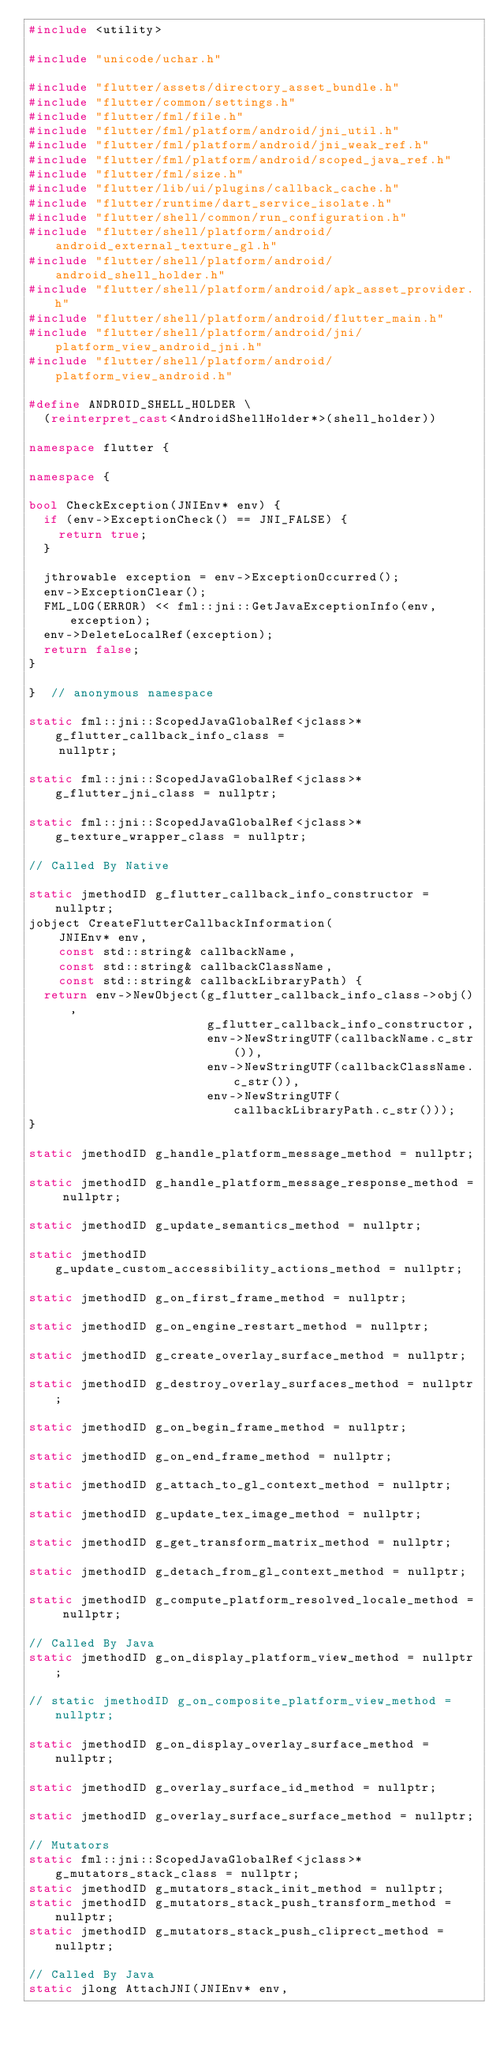Convert code to text. <code><loc_0><loc_0><loc_500><loc_500><_C++_>#include <utility>

#include "unicode/uchar.h"

#include "flutter/assets/directory_asset_bundle.h"
#include "flutter/common/settings.h"
#include "flutter/fml/file.h"
#include "flutter/fml/platform/android/jni_util.h"
#include "flutter/fml/platform/android/jni_weak_ref.h"
#include "flutter/fml/platform/android/scoped_java_ref.h"
#include "flutter/fml/size.h"
#include "flutter/lib/ui/plugins/callback_cache.h"
#include "flutter/runtime/dart_service_isolate.h"
#include "flutter/shell/common/run_configuration.h"
#include "flutter/shell/platform/android/android_external_texture_gl.h"
#include "flutter/shell/platform/android/android_shell_holder.h"
#include "flutter/shell/platform/android/apk_asset_provider.h"
#include "flutter/shell/platform/android/flutter_main.h"
#include "flutter/shell/platform/android/jni/platform_view_android_jni.h"
#include "flutter/shell/platform/android/platform_view_android.h"

#define ANDROID_SHELL_HOLDER \
  (reinterpret_cast<AndroidShellHolder*>(shell_holder))

namespace flutter {

namespace {

bool CheckException(JNIEnv* env) {
  if (env->ExceptionCheck() == JNI_FALSE) {
    return true;
  }

  jthrowable exception = env->ExceptionOccurred();
  env->ExceptionClear();
  FML_LOG(ERROR) << fml::jni::GetJavaExceptionInfo(env, exception);
  env->DeleteLocalRef(exception);
  return false;
}

}  // anonymous namespace

static fml::jni::ScopedJavaGlobalRef<jclass>* g_flutter_callback_info_class =
    nullptr;

static fml::jni::ScopedJavaGlobalRef<jclass>* g_flutter_jni_class = nullptr;

static fml::jni::ScopedJavaGlobalRef<jclass>* g_texture_wrapper_class = nullptr;

// Called By Native

static jmethodID g_flutter_callback_info_constructor = nullptr;
jobject CreateFlutterCallbackInformation(
    JNIEnv* env,
    const std::string& callbackName,
    const std::string& callbackClassName,
    const std::string& callbackLibraryPath) {
  return env->NewObject(g_flutter_callback_info_class->obj(),
                        g_flutter_callback_info_constructor,
                        env->NewStringUTF(callbackName.c_str()),
                        env->NewStringUTF(callbackClassName.c_str()),
                        env->NewStringUTF(callbackLibraryPath.c_str()));
}

static jmethodID g_handle_platform_message_method = nullptr;

static jmethodID g_handle_platform_message_response_method = nullptr;

static jmethodID g_update_semantics_method = nullptr;

static jmethodID g_update_custom_accessibility_actions_method = nullptr;

static jmethodID g_on_first_frame_method = nullptr;

static jmethodID g_on_engine_restart_method = nullptr;

static jmethodID g_create_overlay_surface_method = nullptr;

static jmethodID g_destroy_overlay_surfaces_method = nullptr;

static jmethodID g_on_begin_frame_method = nullptr;

static jmethodID g_on_end_frame_method = nullptr;

static jmethodID g_attach_to_gl_context_method = nullptr;

static jmethodID g_update_tex_image_method = nullptr;

static jmethodID g_get_transform_matrix_method = nullptr;

static jmethodID g_detach_from_gl_context_method = nullptr;

static jmethodID g_compute_platform_resolved_locale_method = nullptr;

// Called By Java
static jmethodID g_on_display_platform_view_method = nullptr;

// static jmethodID g_on_composite_platform_view_method = nullptr;

static jmethodID g_on_display_overlay_surface_method = nullptr;

static jmethodID g_overlay_surface_id_method = nullptr;

static jmethodID g_overlay_surface_surface_method = nullptr;

// Mutators
static fml::jni::ScopedJavaGlobalRef<jclass>* g_mutators_stack_class = nullptr;
static jmethodID g_mutators_stack_init_method = nullptr;
static jmethodID g_mutators_stack_push_transform_method = nullptr;
static jmethodID g_mutators_stack_push_cliprect_method = nullptr;

// Called By Java
static jlong AttachJNI(JNIEnv* env,</code> 